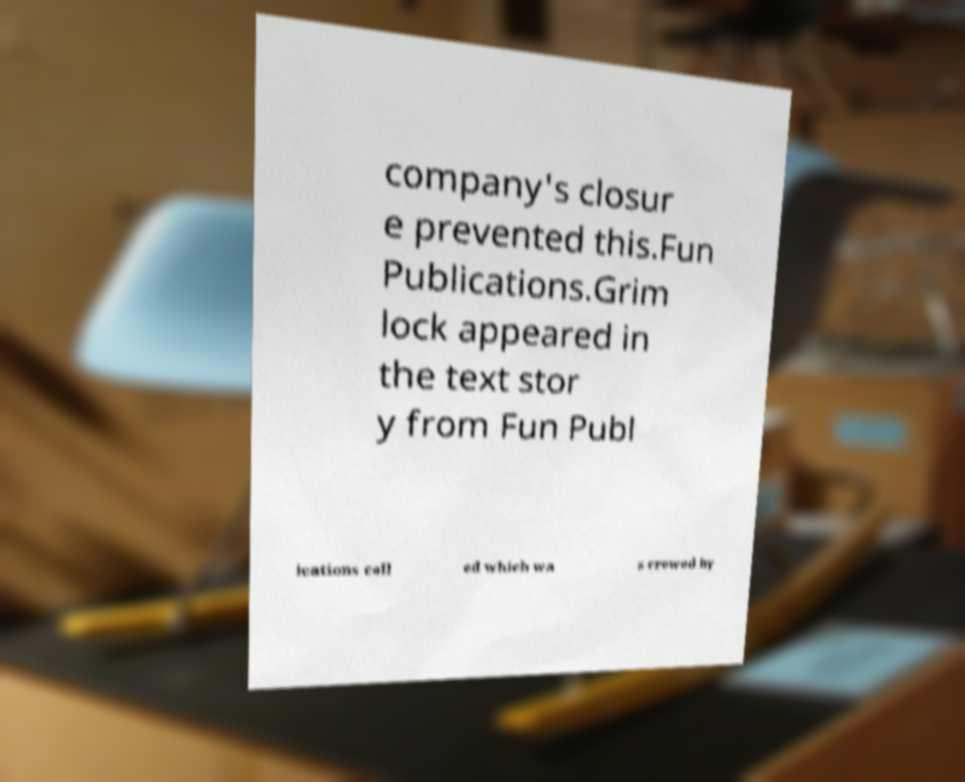What messages or text are displayed in this image? I need them in a readable, typed format. company's closur e prevented this.Fun Publications.Grim lock appeared in the text stor y from Fun Publ ications call ed which wa s crewed by 